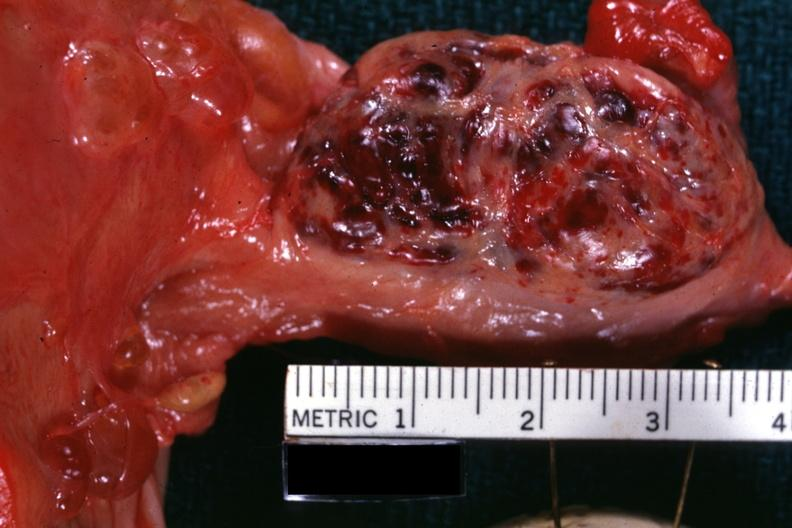what is present?
Answer the question using a single word or phrase. Hemorrhagic corpus luteum 